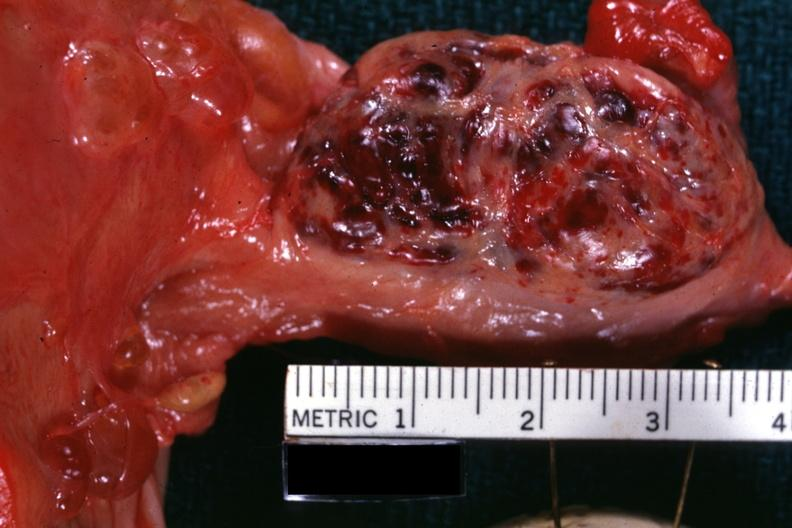what is present?
Answer the question using a single word or phrase. Hemorrhagic corpus luteum 